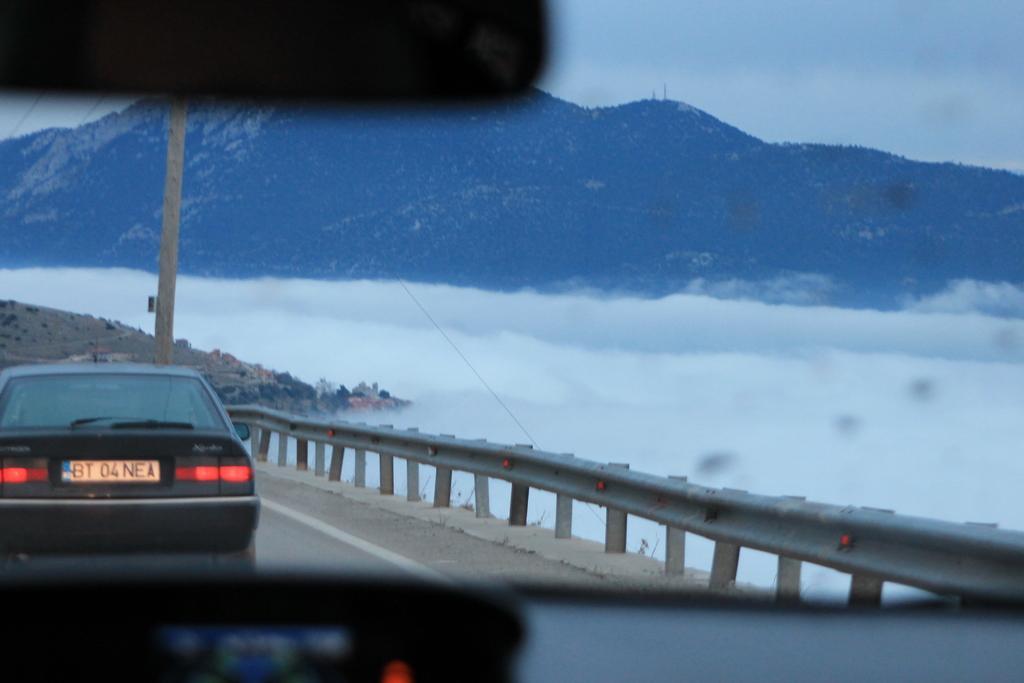Please provide a concise description of this image. In this picture we can observe a car on the road. There is a railing on the right side of the road. We can observe a pole on the left side. In the background there are hills and a sky. 